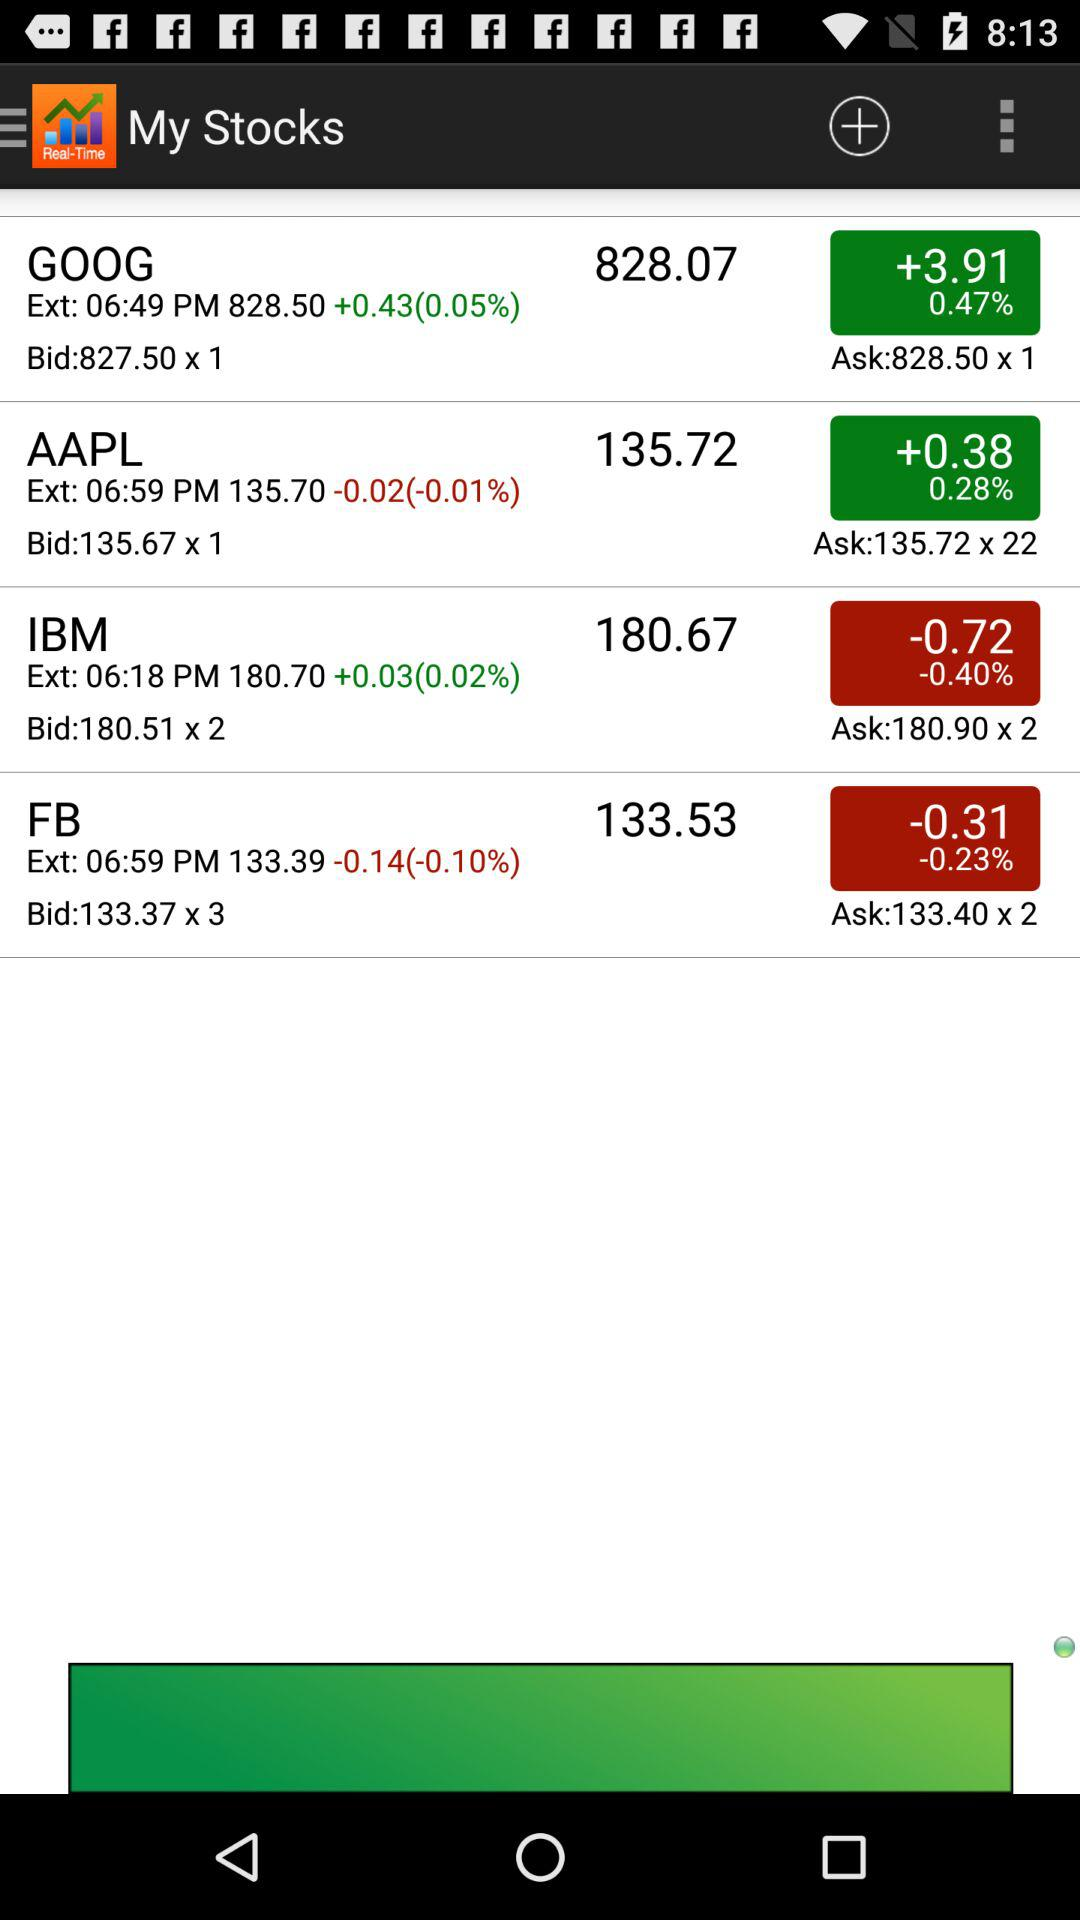What is the name of the application? The name of the application is "My Stocks". 